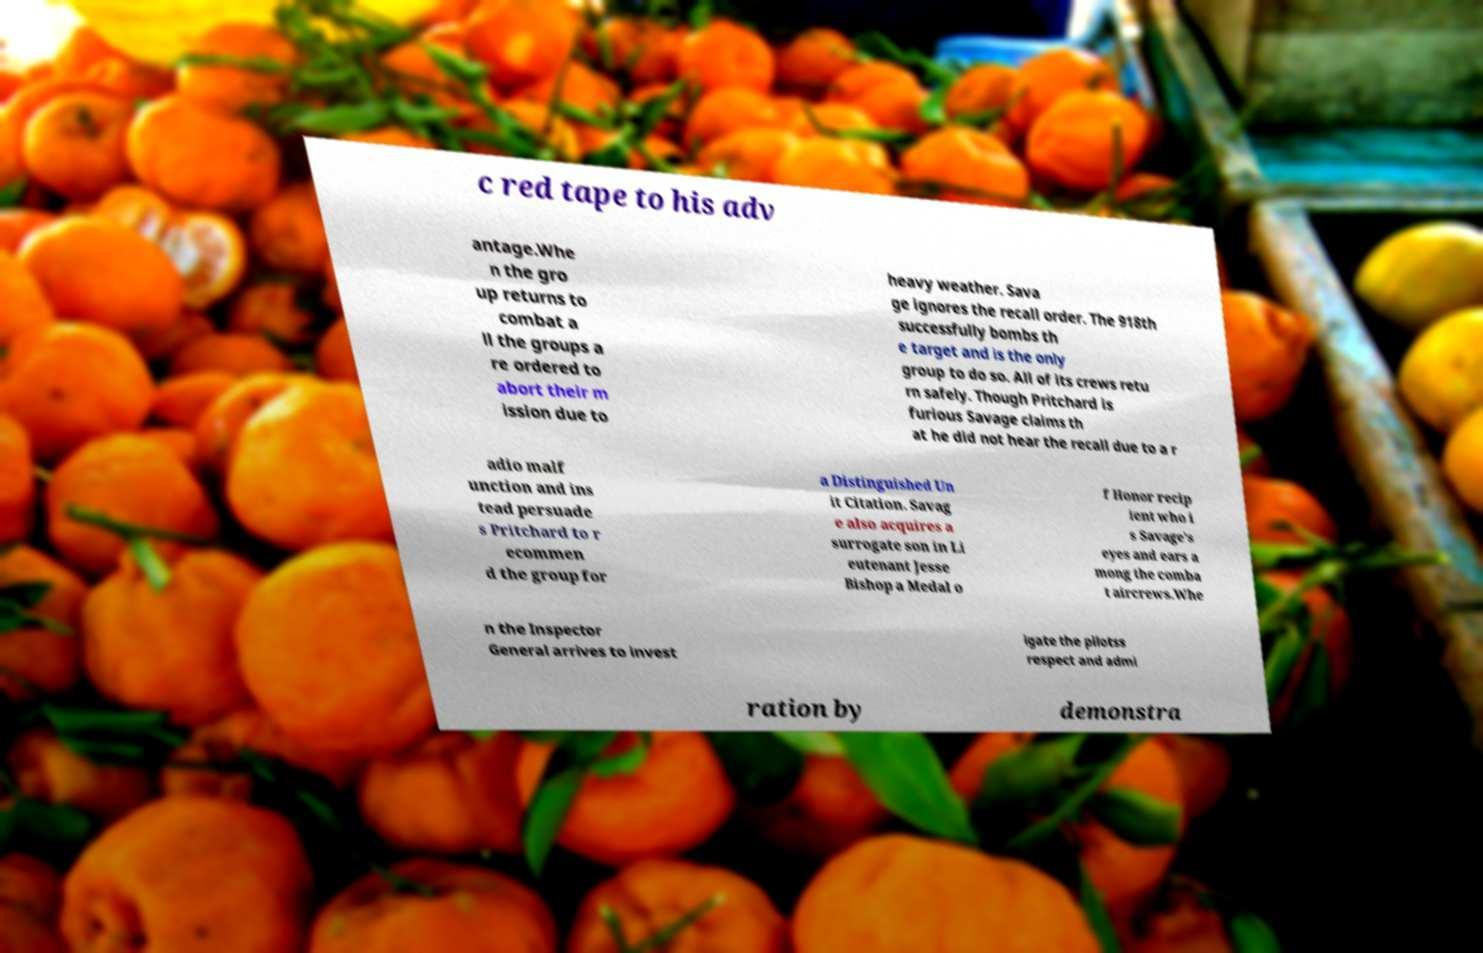Please identify and transcribe the text found in this image. c red tape to his adv antage.Whe n the gro up returns to combat a ll the groups a re ordered to abort their m ission due to heavy weather. Sava ge ignores the recall order. The 918th successfully bombs th e target and is the only group to do so. All of its crews retu rn safely. Though Pritchard is furious Savage claims th at he did not hear the recall due to a r adio malf unction and ins tead persuade s Pritchard to r ecommen d the group for a Distinguished Un it Citation. Savag e also acquires a surrogate son in Li eutenant Jesse Bishop a Medal o f Honor recip ient who i s Savage's eyes and ears a mong the comba t aircrews.Whe n the Inspector General arrives to invest igate the pilotss respect and admi ration by demonstra 